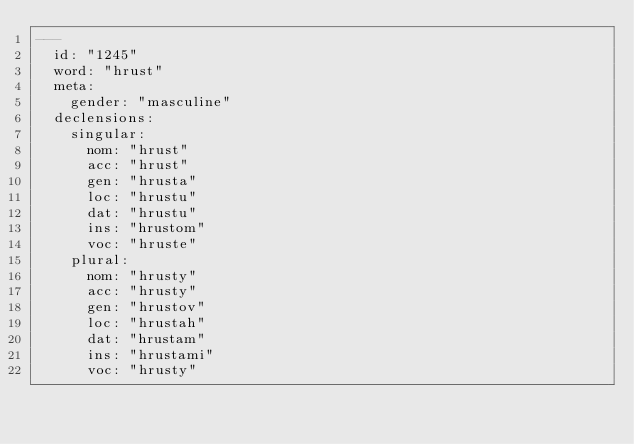Convert code to text. <code><loc_0><loc_0><loc_500><loc_500><_YAML_>---
  id: "1245"
  word: "hrust"
  meta: 
    gender: "masculine"
  declensions: 
    singular: 
      nom: "hrust"
      acc: "hrust"
      gen: "hrusta"
      loc: "hrustu"
      dat: "hrustu"
      ins: "hrustom"
      voc: "hruste"
    plural: 
      nom: "hrusty"
      acc: "hrusty"
      gen: "hrustov"
      loc: "hrustah"
      dat: "hrustam"
      ins: "hrustami"
      voc: "hrusty"
</code> 